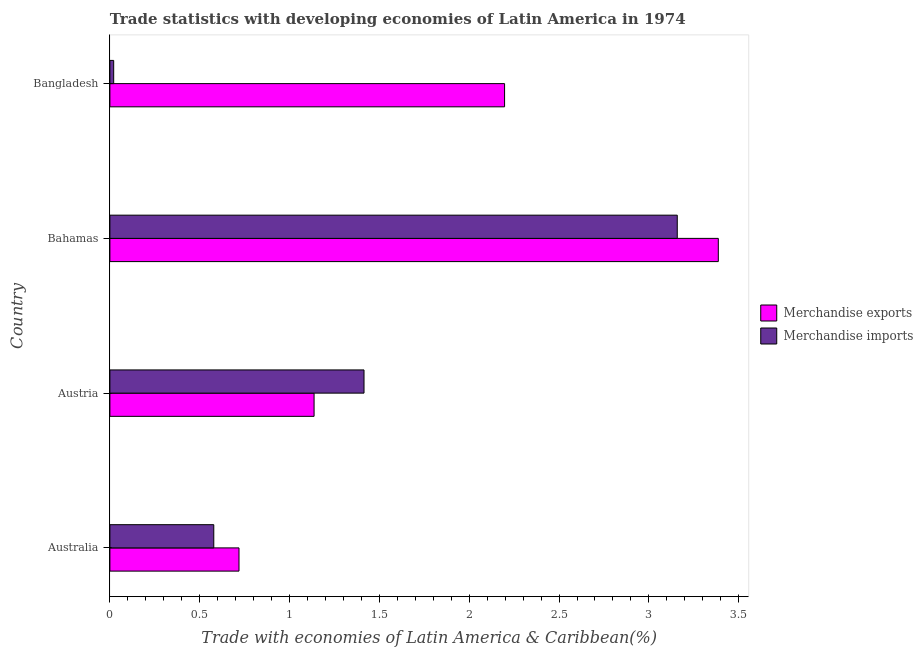How many different coloured bars are there?
Provide a succinct answer. 2. Are the number of bars per tick equal to the number of legend labels?
Offer a very short reply. Yes. Are the number of bars on each tick of the Y-axis equal?
Offer a very short reply. Yes. How many bars are there on the 2nd tick from the top?
Make the answer very short. 2. How many bars are there on the 3rd tick from the bottom?
Provide a short and direct response. 2. What is the label of the 2nd group of bars from the top?
Ensure brevity in your answer.  Bahamas. What is the merchandise exports in Bangladesh?
Offer a terse response. 2.2. Across all countries, what is the maximum merchandise exports?
Your answer should be compact. 3.39. Across all countries, what is the minimum merchandise imports?
Make the answer very short. 0.02. In which country was the merchandise imports maximum?
Make the answer very short. Bahamas. What is the total merchandise exports in the graph?
Your response must be concise. 7.44. What is the difference between the merchandise imports in Austria and that in Bahamas?
Provide a short and direct response. -1.74. What is the difference between the merchandise imports in Bangladesh and the merchandise exports in Australia?
Offer a terse response. -0.7. What is the average merchandise imports per country?
Keep it short and to the point. 1.29. What is the difference between the merchandise exports and merchandise imports in Bahamas?
Offer a terse response. 0.23. What is the ratio of the merchandise imports in Australia to that in Austria?
Offer a very short reply. 0.41. Is the merchandise imports in Australia less than that in Austria?
Provide a short and direct response. Yes. What is the difference between the highest and the second highest merchandise exports?
Give a very brief answer. 1.19. What is the difference between the highest and the lowest merchandise imports?
Offer a very short reply. 3.14. What does the 1st bar from the bottom in Bangladesh represents?
Provide a succinct answer. Merchandise exports. Are all the bars in the graph horizontal?
Provide a succinct answer. Yes. How many countries are there in the graph?
Give a very brief answer. 4. Does the graph contain any zero values?
Provide a succinct answer. No. Where does the legend appear in the graph?
Offer a very short reply. Center right. How many legend labels are there?
Offer a very short reply. 2. How are the legend labels stacked?
Give a very brief answer. Vertical. What is the title of the graph?
Your response must be concise. Trade statistics with developing economies of Latin America in 1974. What is the label or title of the X-axis?
Your answer should be compact. Trade with economies of Latin America & Caribbean(%). What is the Trade with economies of Latin America & Caribbean(%) in Merchandise exports in Australia?
Your answer should be very brief. 0.72. What is the Trade with economies of Latin America & Caribbean(%) in Merchandise imports in Australia?
Provide a short and direct response. 0.58. What is the Trade with economies of Latin America & Caribbean(%) of Merchandise exports in Austria?
Provide a short and direct response. 1.14. What is the Trade with economies of Latin America & Caribbean(%) in Merchandise imports in Austria?
Offer a terse response. 1.41. What is the Trade with economies of Latin America & Caribbean(%) in Merchandise exports in Bahamas?
Ensure brevity in your answer.  3.39. What is the Trade with economies of Latin America & Caribbean(%) of Merchandise imports in Bahamas?
Your response must be concise. 3.16. What is the Trade with economies of Latin America & Caribbean(%) of Merchandise exports in Bangladesh?
Provide a short and direct response. 2.2. What is the Trade with economies of Latin America & Caribbean(%) in Merchandise imports in Bangladesh?
Provide a short and direct response. 0.02. Across all countries, what is the maximum Trade with economies of Latin America & Caribbean(%) of Merchandise exports?
Give a very brief answer. 3.39. Across all countries, what is the maximum Trade with economies of Latin America & Caribbean(%) in Merchandise imports?
Provide a short and direct response. 3.16. Across all countries, what is the minimum Trade with economies of Latin America & Caribbean(%) of Merchandise exports?
Provide a short and direct response. 0.72. Across all countries, what is the minimum Trade with economies of Latin America & Caribbean(%) of Merchandise imports?
Provide a succinct answer. 0.02. What is the total Trade with economies of Latin America & Caribbean(%) of Merchandise exports in the graph?
Your response must be concise. 7.44. What is the total Trade with economies of Latin America & Caribbean(%) of Merchandise imports in the graph?
Your answer should be very brief. 5.17. What is the difference between the Trade with economies of Latin America & Caribbean(%) of Merchandise exports in Australia and that in Austria?
Provide a short and direct response. -0.42. What is the difference between the Trade with economies of Latin America & Caribbean(%) of Merchandise imports in Australia and that in Austria?
Your response must be concise. -0.84. What is the difference between the Trade with economies of Latin America & Caribbean(%) in Merchandise exports in Australia and that in Bahamas?
Your response must be concise. -2.67. What is the difference between the Trade with economies of Latin America & Caribbean(%) in Merchandise imports in Australia and that in Bahamas?
Offer a terse response. -2.58. What is the difference between the Trade with economies of Latin America & Caribbean(%) of Merchandise exports in Australia and that in Bangladesh?
Provide a short and direct response. -1.48. What is the difference between the Trade with economies of Latin America & Caribbean(%) of Merchandise imports in Australia and that in Bangladesh?
Your answer should be compact. 0.56. What is the difference between the Trade with economies of Latin America & Caribbean(%) in Merchandise exports in Austria and that in Bahamas?
Give a very brief answer. -2.25. What is the difference between the Trade with economies of Latin America & Caribbean(%) in Merchandise imports in Austria and that in Bahamas?
Offer a terse response. -1.74. What is the difference between the Trade with economies of Latin America & Caribbean(%) in Merchandise exports in Austria and that in Bangladesh?
Your answer should be very brief. -1.06. What is the difference between the Trade with economies of Latin America & Caribbean(%) in Merchandise imports in Austria and that in Bangladesh?
Your answer should be very brief. 1.39. What is the difference between the Trade with economies of Latin America & Caribbean(%) of Merchandise exports in Bahamas and that in Bangladesh?
Provide a succinct answer. 1.19. What is the difference between the Trade with economies of Latin America & Caribbean(%) in Merchandise imports in Bahamas and that in Bangladesh?
Your response must be concise. 3.14. What is the difference between the Trade with economies of Latin America & Caribbean(%) of Merchandise exports in Australia and the Trade with economies of Latin America & Caribbean(%) of Merchandise imports in Austria?
Your answer should be compact. -0.7. What is the difference between the Trade with economies of Latin America & Caribbean(%) of Merchandise exports in Australia and the Trade with economies of Latin America & Caribbean(%) of Merchandise imports in Bahamas?
Give a very brief answer. -2.44. What is the difference between the Trade with economies of Latin America & Caribbean(%) in Merchandise exports in Australia and the Trade with economies of Latin America & Caribbean(%) in Merchandise imports in Bangladesh?
Your answer should be very brief. 0.7. What is the difference between the Trade with economies of Latin America & Caribbean(%) in Merchandise exports in Austria and the Trade with economies of Latin America & Caribbean(%) in Merchandise imports in Bahamas?
Ensure brevity in your answer.  -2.02. What is the difference between the Trade with economies of Latin America & Caribbean(%) of Merchandise exports in Austria and the Trade with economies of Latin America & Caribbean(%) of Merchandise imports in Bangladesh?
Your response must be concise. 1.12. What is the difference between the Trade with economies of Latin America & Caribbean(%) of Merchandise exports in Bahamas and the Trade with economies of Latin America & Caribbean(%) of Merchandise imports in Bangladesh?
Give a very brief answer. 3.37. What is the average Trade with economies of Latin America & Caribbean(%) of Merchandise exports per country?
Make the answer very short. 1.86. What is the average Trade with economies of Latin America & Caribbean(%) in Merchandise imports per country?
Provide a succinct answer. 1.29. What is the difference between the Trade with economies of Latin America & Caribbean(%) in Merchandise exports and Trade with economies of Latin America & Caribbean(%) in Merchandise imports in Australia?
Provide a succinct answer. 0.14. What is the difference between the Trade with economies of Latin America & Caribbean(%) of Merchandise exports and Trade with economies of Latin America & Caribbean(%) of Merchandise imports in Austria?
Offer a terse response. -0.28. What is the difference between the Trade with economies of Latin America & Caribbean(%) in Merchandise exports and Trade with economies of Latin America & Caribbean(%) in Merchandise imports in Bahamas?
Give a very brief answer. 0.23. What is the difference between the Trade with economies of Latin America & Caribbean(%) in Merchandise exports and Trade with economies of Latin America & Caribbean(%) in Merchandise imports in Bangladesh?
Provide a short and direct response. 2.18. What is the ratio of the Trade with economies of Latin America & Caribbean(%) in Merchandise exports in Australia to that in Austria?
Offer a terse response. 0.63. What is the ratio of the Trade with economies of Latin America & Caribbean(%) in Merchandise imports in Australia to that in Austria?
Your response must be concise. 0.41. What is the ratio of the Trade with economies of Latin America & Caribbean(%) in Merchandise exports in Australia to that in Bahamas?
Your response must be concise. 0.21. What is the ratio of the Trade with economies of Latin America & Caribbean(%) in Merchandise imports in Australia to that in Bahamas?
Offer a terse response. 0.18. What is the ratio of the Trade with economies of Latin America & Caribbean(%) in Merchandise exports in Australia to that in Bangladesh?
Offer a terse response. 0.33. What is the ratio of the Trade with economies of Latin America & Caribbean(%) of Merchandise imports in Australia to that in Bangladesh?
Provide a short and direct response. 27.38. What is the ratio of the Trade with economies of Latin America & Caribbean(%) of Merchandise exports in Austria to that in Bahamas?
Provide a succinct answer. 0.34. What is the ratio of the Trade with economies of Latin America & Caribbean(%) in Merchandise imports in Austria to that in Bahamas?
Keep it short and to the point. 0.45. What is the ratio of the Trade with economies of Latin America & Caribbean(%) in Merchandise exports in Austria to that in Bangladesh?
Your answer should be very brief. 0.52. What is the ratio of the Trade with economies of Latin America & Caribbean(%) of Merchandise imports in Austria to that in Bangladesh?
Your answer should be very brief. 66.97. What is the ratio of the Trade with economies of Latin America & Caribbean(%) of Merchandise exports in Bahamas to that in Bangladesh?
Give a very brief answer. 1.54. What is the ratio of the Trade with economies of Latin America & Caribbean(%) of Merchandise imports in Bahamas to that in Bangladesh?
Give a very brief answer. 149.52. What is the difference between the highest and the second highest Trade with economies of Latin America & Caribbean(%) of Merchandise exports?
Offer a terse response. 1.19. What is the difference between the highest and the second highest Trade with economies of Latin America & Caribbean(%) of Merchandise imports?
Make the answer very short. 1.74. What is the difference between the highest and the lowest Trade with economies of Latin America & Caribbean(%) of Merchandise exports?
Your answer should be very brief. 2.67. What is the difference between the highest and the lowest Trade with economies of Latin America & Caribbean(%) in Merchandise imports?
Keep it short and to the point. 3.14. 